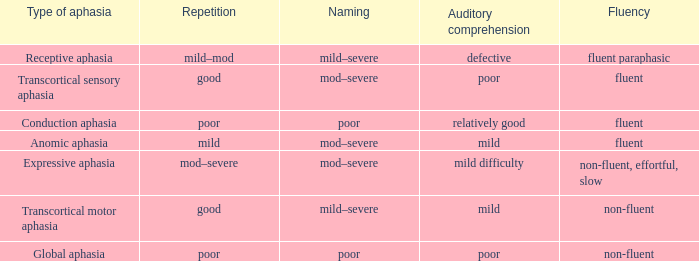Name the number of naming for anomic aphasia 1.0. Would you be able to parse every entry in this table? {'header': ['Type of aphasia', 'Repetition', 'Naming', 'Auditory comprehension', 'Fluency'], 'rows': [['Receptive aphasia', 'mild–mod', 'mild–severe', 'defective', 'fluent paraphasic'], ['Transcortical sensory aphasia', 'good', 'mod–severe', 'poor', 'fluent'], ['Conduction aphasia', 'poor', 'poor', 'relatively good', 'fluent'], ['Anomic aphasia', 'mild', 'mod–severe', 'mild', 'fluent'], ['Expressive aphasia', 'mod–severe', 'mod–severe', 'mild difficulty', 'non-fluent, effortful, slow'], ['Transcortical motor aphasia', 'good', 'mild–severe', 'mild', 'non-fluent'], ['Global aphasia', 'poor', 'poor', 'poor', 'non-fluent']]} 